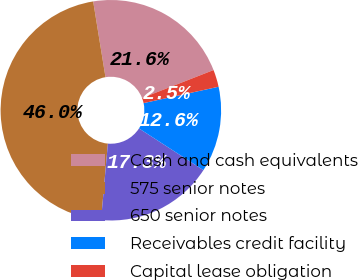Convert chart to OTSL. <chart><loc_0><loc_0><loc_500><loc_500><pie_chart><fcel>Cash and cash equivalents<fcel>575 senior notes<fcel>650 senior notes<fcel>Receivables credit facility<fcel>Capital lease obligation<nl><fcel>21.63%<fcel>46.02%<fcel>17.28%<fcel>12.56%<fcel>2.52%<nl></chart> 